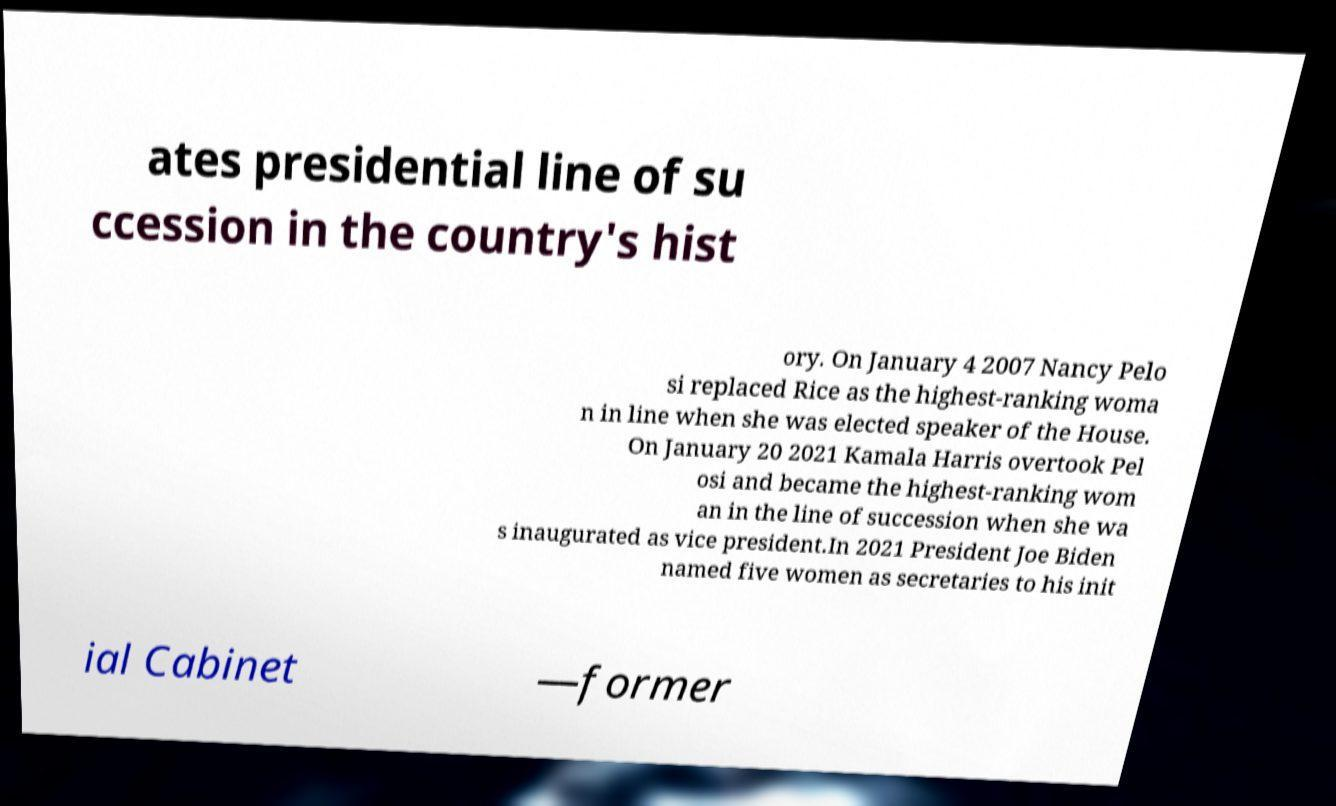For documentation purposes, I need the text within this image transcribed. Could you provide that? ates presidential line of su ccession in the country's hist ory. On January 4 2007 Nancy Pelo si replaced Rice as the highest-ranking woma n in line when she was elected speaker of the House. On January 20 2021 Kamala Harris overtook Pel osi and became the highest-ranking wom an in the line of succession when she wa s inaugurated as vice president.In 2021 President Joe Biden named five women as secretaries to his init ial Cabinet —former 